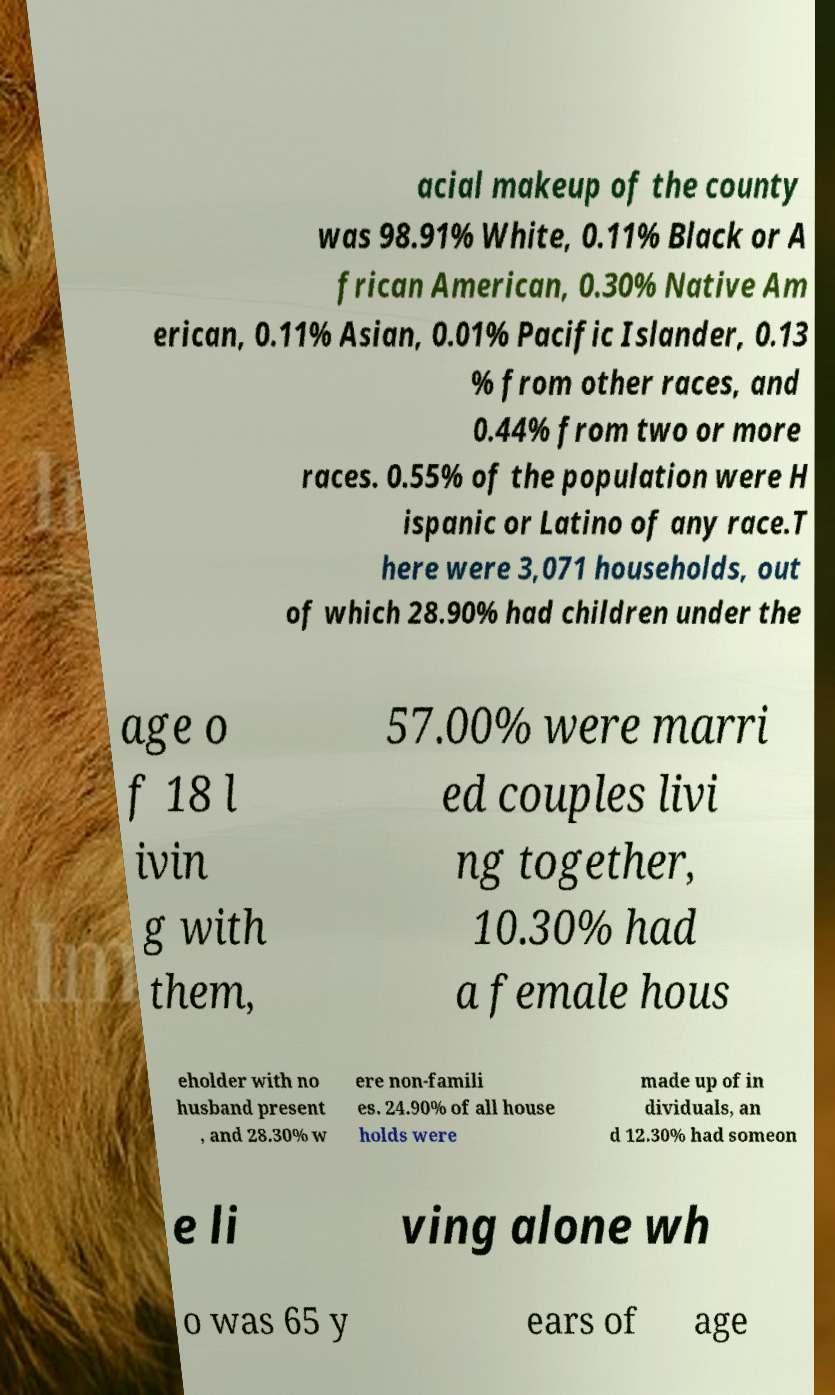Please read and relay the text visible in this image. What does it say? acial makeup of the county was 98.91% White, 0.11% Black or A frican American, 0.30% Native Am erican, 0.11% Asian, 0.01% Pacific Islander, 0.13 % from other races, and 0.44% from two or more races. 0.55% of the population were H ispanic or Latino of any race.T here were 3,071 households, out of which 28.90% had children under the age o f 18 l ivin g with them, 57.00% were marri ed couples livi ng together, 10.30% had a female hous eholder with no husband present , and 28.30% w ere non-famili es. 24.90% of all house holds were made up of in dividuals, an d 12.30% had someon e li ving alone wh o was 65 y ears of age 